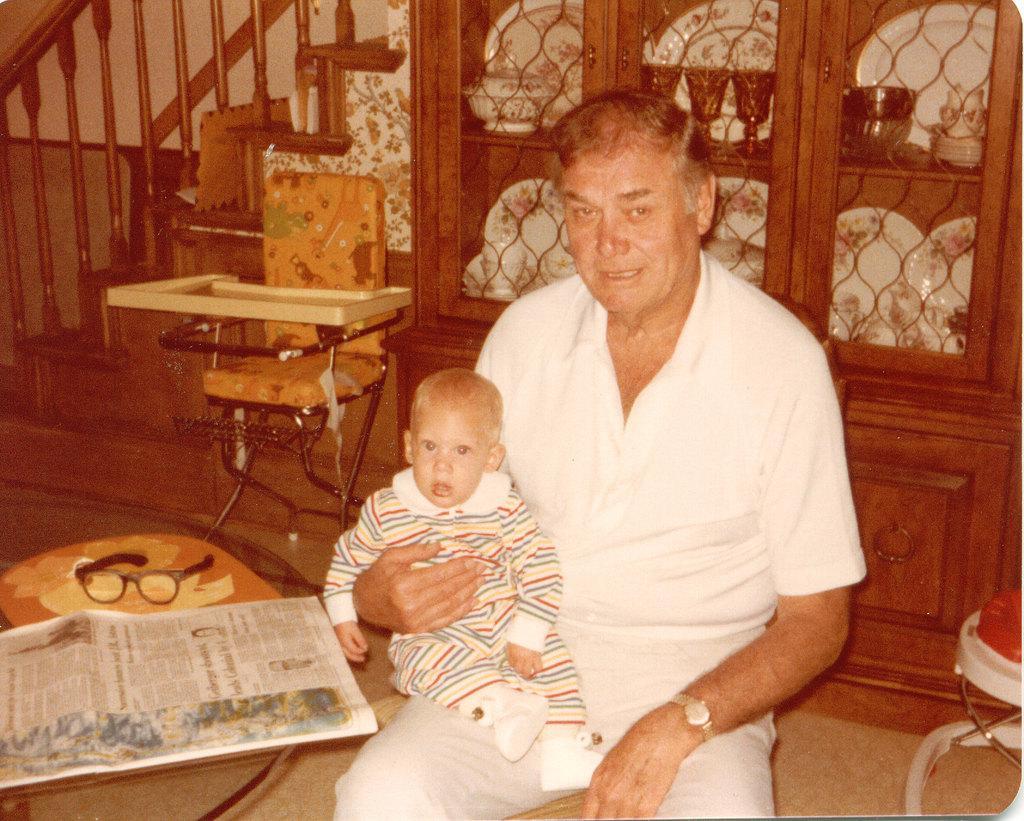In one or two sentences, can you explain what this image depicts? In this image I see a man who is holding a baby and there is a table over here on which there is a paper and a spectacle. In the background I see the chair, stairs and the cupboard in which there are few things in it. 